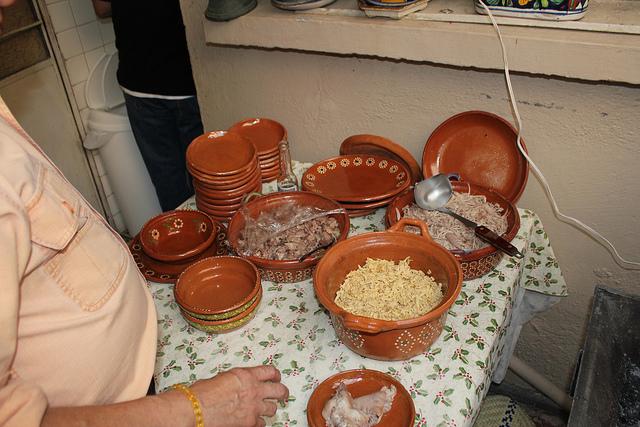How many bowls have food in them?
Give a very brief answer. 4. If left out well this food spoil?
Answer briefly. Yes. What color are the bowls?
Answer briefly. Brown. 